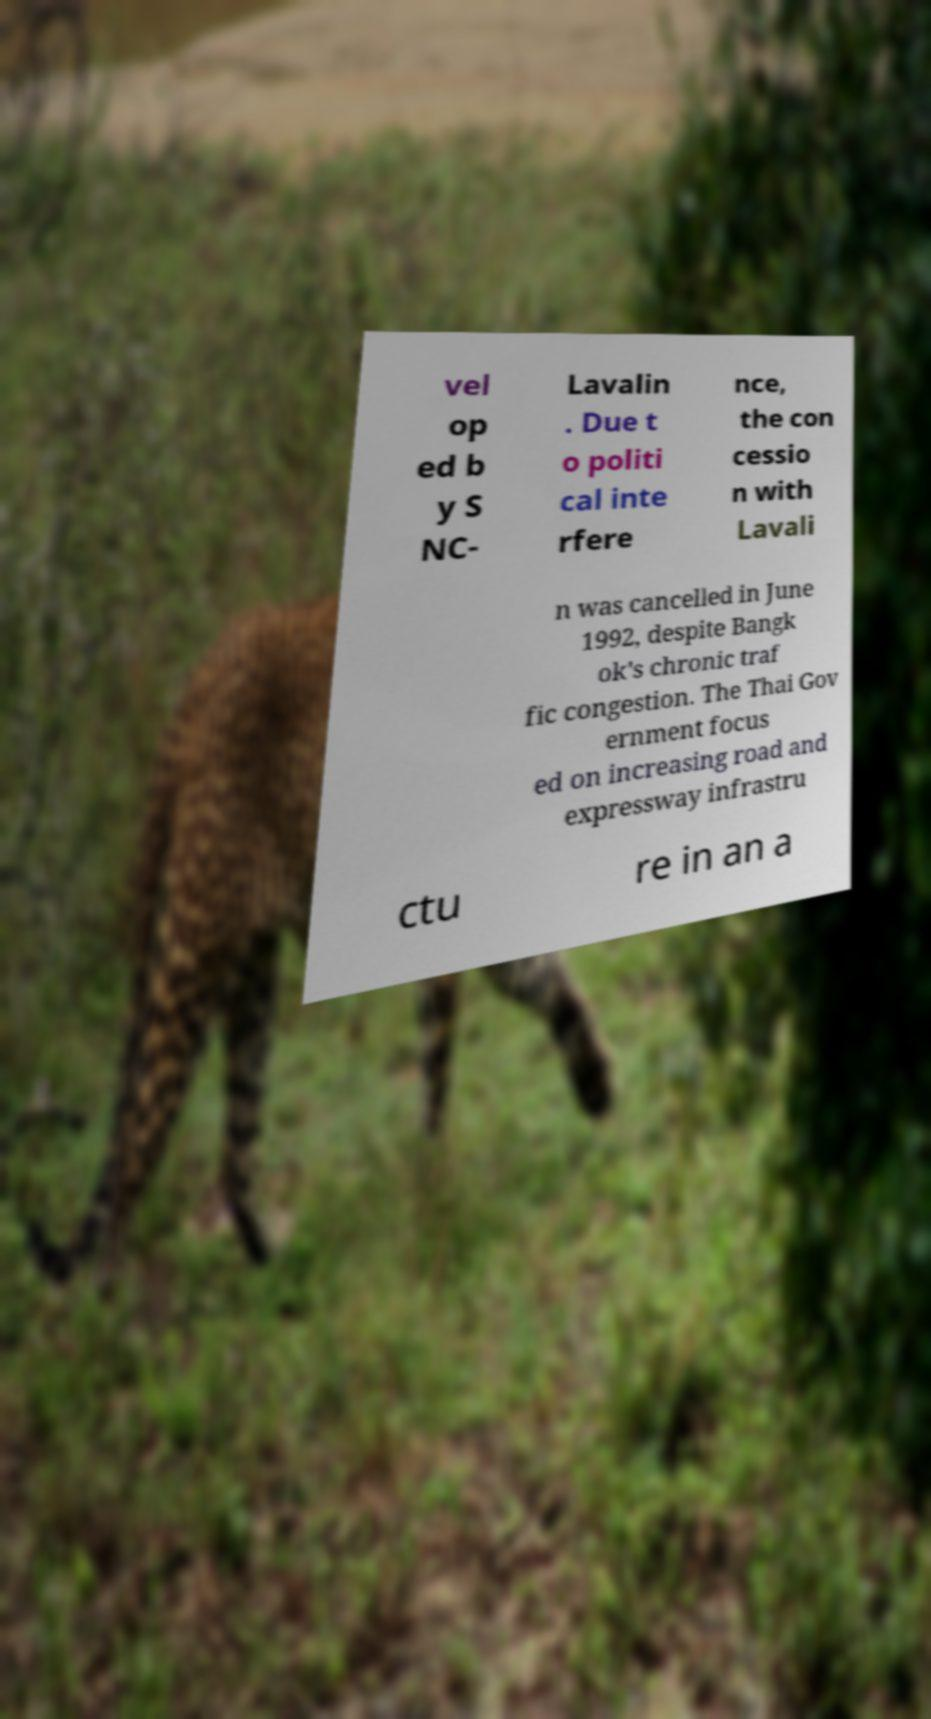For documentation purposes, I need the text within this image transcribed. Could you provide that? vel op ed b y S NC- Lavalin . Due t o politi cal inte rfere nce, the con cessio n with Lavali n was cancelled in June 1992, despite Bangk ok's chronic traf fic congestion. The Thai Gov ernment focus ed on increasing road and expressway infrastru ctu re in an a 